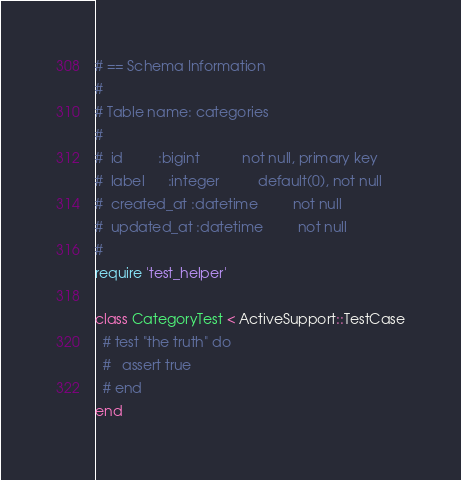<code> <loc_0><loc_0><loc_500><loc_500><_Ruby_># == Schema Information
#
# Table name: categories
#
#  id         :bigint           not null, primary key
#  label      :integer          default(0), not null
#  created_at :datetime         not null
#  updated_at :datetime         not null
#
require 'test_helper'

class CategoryTest < ActiveSupport::TestCase
  # test "the truth" do
  #   assert true
  # end
end
</code> 